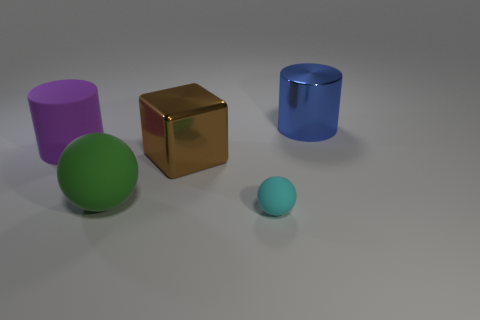Add 4 blue cubes. How many objects exist? 9 Subtract 1 balls. How many balls are left? 1 Subtract all cylinders. How many objects are left? 3 Add 3 rubber objects. How many rubber objects are left? 6 Add 2 green rubber blocks. How many green rubber blocks exist? 2 Subtract 1 green spheres. How many objects are left? 4 Subtract all gray cylinders. Subtract all red balls. How many cylinders are left? 2 Subtract all small brown objects. Subtract all large blue shiny things. How many objects are left? 4 